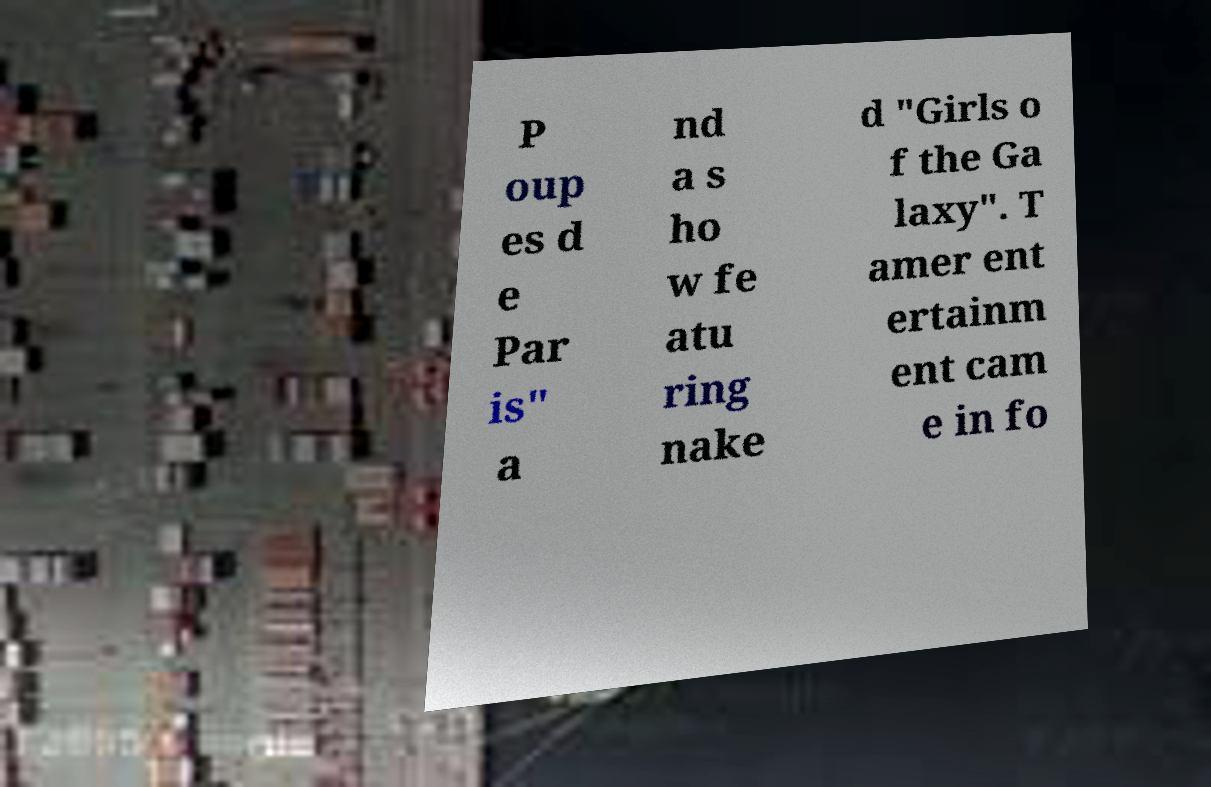For documentation purposes, I need the text within this image transcribed. Could you provide that? P oup es d e Par is" a nd a s ho w fe atu ring nake d "Girls o f the Ga laxy". T amer ent ertainm ent cam e in fo 